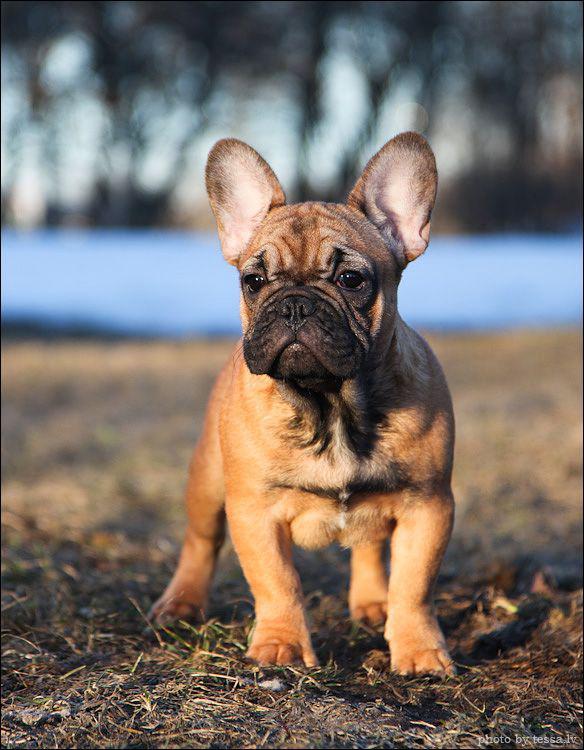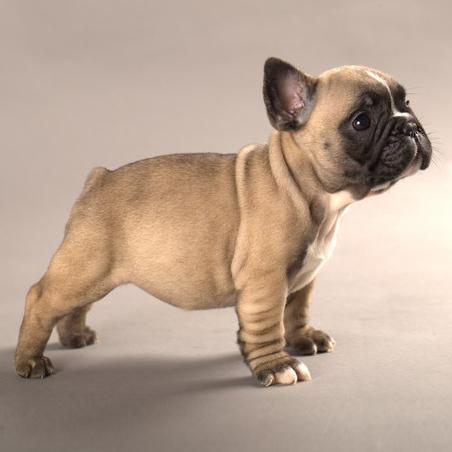The first image is the image on the left, the second image is the image on the right. Considering the images on both sides, is "One dog is wearing something around his neck." valid? Answer yes or no. No. The first image is the image on the left, the second image is the image on the right. Evaluate the accuracy of this statement regarding the images: "Each image shows one dog standing on all fours, and one image shows a dog standing with its body in profile.". Is it true? Answer yes or no. Yes. 